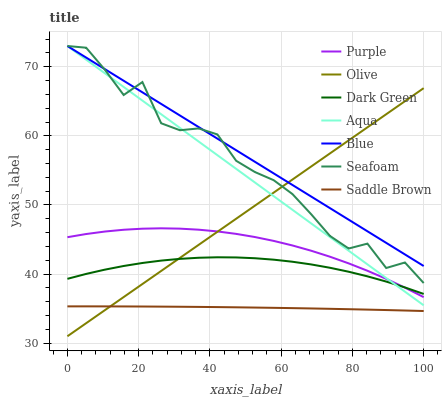Does Saddle Brown have the minimum area under the curve?
Answer yes or no. Yes. Does Blue have the maximum area under the curve?
Answer yes or no. Yes. Does Purple have the minimum area under the curve?
Answer yes or no. No. Does Purple have the maximum area under the curve?
Answer yes or no. No. Is Olive the smoothest?
Answer yes or no. Yes. Is Seafoam the roughest?
Answer yes or no. Yes. Is Purple the smoothest?
Answer yes or no. No. Is Purple the roughest?
Answer yes or no. No. Does Purple have the lowest value?
Answer yes or no. No. Does Seafoam have the highest value?
Answer yes or no. Yes. Does Purple have the highest value?
Answer yes or no. No. Is Saddle Brown less than Purple?
Answer yes or no. Yes. Is Purple greater than Saddle Brown?
Answer yes or no. Yes. Does Blue intersect Seafoam?
Answer yes or no. Yes. Is Blue less than Seafoam?
Answer yes or no. No. Is Blue greater than Seafoam?
Answer yes or no. No. Does Saddle Brown intersect Purple?
Answer yes or no. No. 